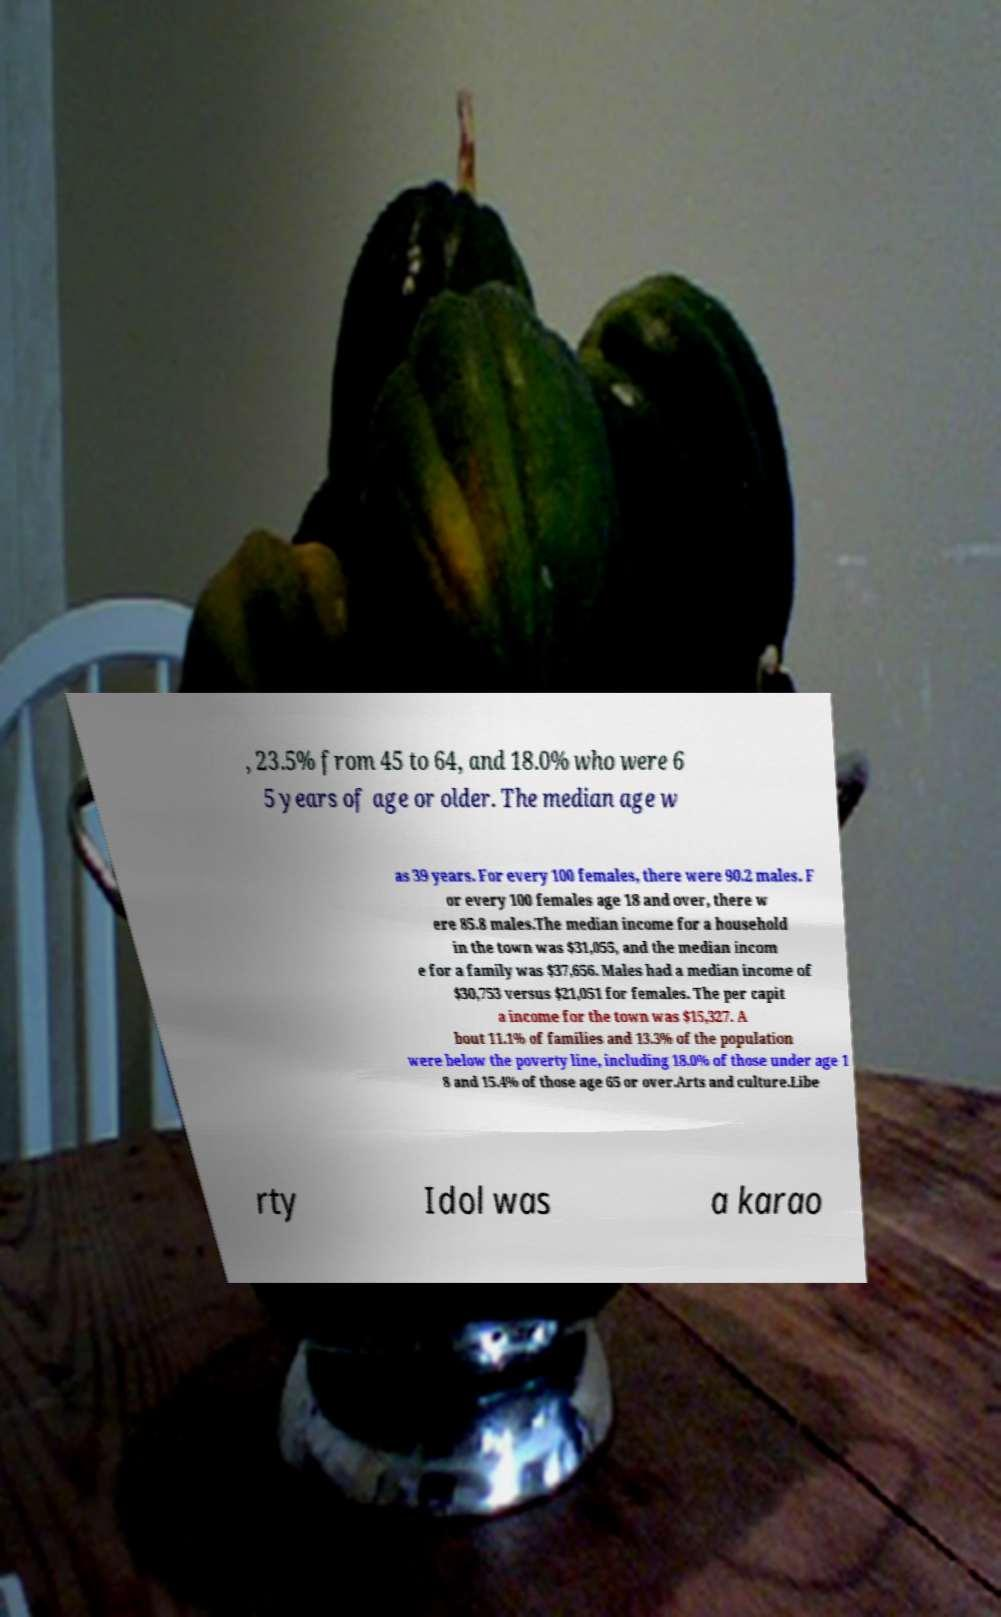For documentation purposes, I need the text within this image transcribed. Could you provide that? , 23.5% from 45 to 64, and 18.0% who were 6 5 years of age or older. The median age w as 39 years. For every 100 females, there were 90.2 males. F or every 100 females age 18 and over, there w ere 85.8 males.The median income for a household in the town was $31,055, and the median incom e for a family was $37,656. Males had a median income of $30,753 versus $21,051 for females. The per capit a income for the town was $15,327. A bout 11.1% of families and 13.3% of the population were below the poverty line, including 18.0% of those under age 1 8 and 15.4% of those age 65 or over.Arts and culture.Libe rty Idol was a karao 